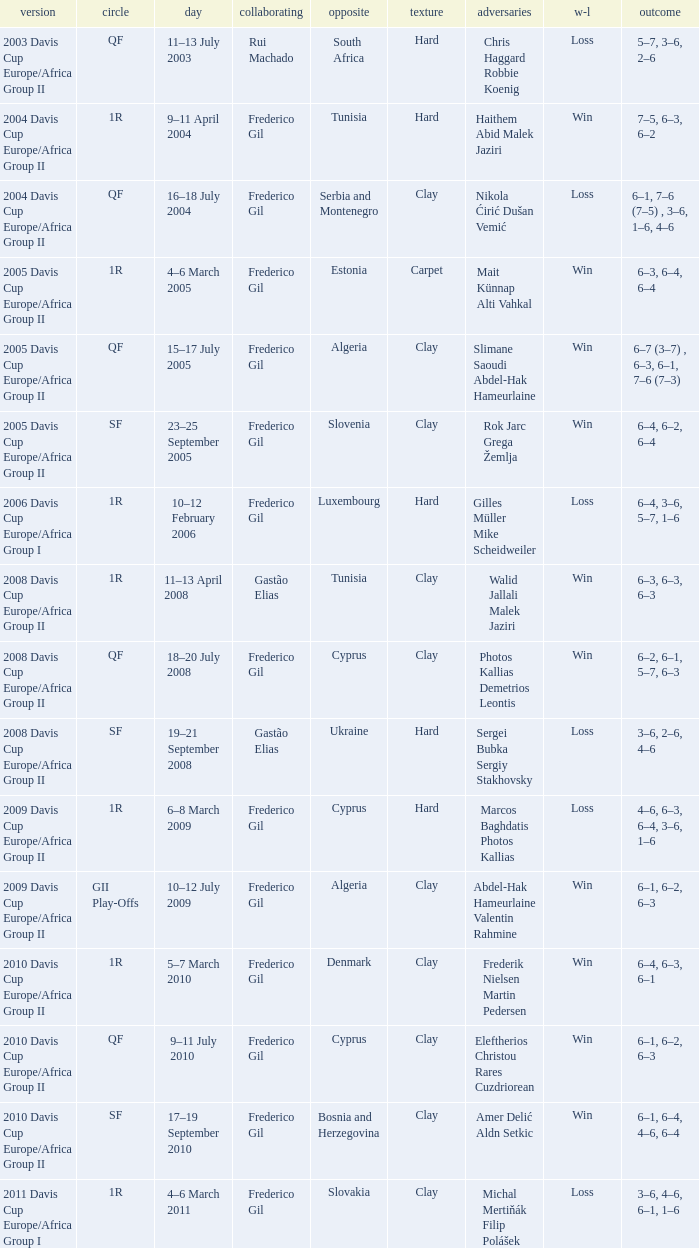How many rounds were there in the 2006 davis cup europe/africa group I? 1.0. Give me the full table as a dictionary. {'header': ['version', 'circle', 'day', 'collaborating', 'opposite', 'texture', 'adversaries', 'w-l', 'outcome'], 'rows': [['2003 Davis Cup Europe/Africa Group II', 'QF', '11–13 July 2003', 'Rui Machado', 'South Africa', 'Hard', 'Chris Haggard Robbie Koenig', 'Loss', '5–7, 3–6, 2–6'], ['2004 Davis Cup Europe/Africa Group II', '1R', '9–11 April 2004', 'Frederico Gil', 'Tunisia', 'Hard', 'Haithem Abid Malek Jaziri', 'Win', '7–5, 6–3, 6–2'], ['2004 Davis Cup Europe/Africa Group II', 'QF', '16–18 July 2004', 'Frederico Gil', 'Serbia and Montenegro', 'Clay', 'Nikola Ćirić Dušan Vemić', 'Loss', '6–1, 7–6 (7–5) , 3–6, 1–6, 4–6'], ['2005 Davis Cup Europe/Africa Group II', '1R', '4–6 March 2005', 'Frederico Gil', 'Estonia', 'Carpet', 'Mait Künnap Alti Vahkal', 'Win', '6–3, 6–4, 6–4'], ['2005 Davis Cup Europe/Africa Group II', 'QF', '15–17 July 2005', 'Frederico Gil', 'Algeria', 'Clay', 'Slimane Saoudi Abdel-Hak Hameurlaine', 'Win', '6–7 (3–7) , 6–3, 6–1, 7–6 (7–3)'], ['2005 Davis Cup Europe/Africa Group II', 'SF', '23–25 September 2005', 'Frederico Gil', 'Slovenia', 'Clay', 'Rok Jarc Grega Žemlja', 'Win', '6–4, 6–2, 6–4'], ['2006 Davis Cup Europe/Africa Group I', '1R', '10–12 February 2006', 'Frederico Gil', 'Luxembourg', 'Hard', 'Gilles Müller Mike Scheidweiler', 'Loss', '6–4, 3–6, 5–7, 1–6'], ['2008 Davis Cup Europe/Africa Group II', '1R', '11–13 April 2008', 'Gastão Elias', 'Tunisia', 'Clay', 'Walid Jallali Malek Jaziri', 'Win', '6–3, 6–3, 6–3'], ['2008 Davis Cup Europe/Africa Group II', 'QF', '18–20 July 2008', 'Frederico Gil', 'Cyprus', 'Clay', 'Photos Kallias Demetrios Leontis', 'Win', '6–2, 6–1, 5–7, 6–3'], ['2008 Davis Cup Europe/Africa Group II', 'SF', '19–21 September 2008', 'Gastão Elias', 'Ukraine', 'Hard', 'Sergei Bubka Sergiy Stakhovsky', 'Loss', '3–6, 2–6, 4–6'], ['2009 Davis Cup Europe/Africa Group II', '1R', '6–8 March 2009', 'Frederico Gil', 'Cyprus', 'Hard', 'Marcos Baghdatis Photos Kallias', 'Loss', '4–6, 6–3, 6–4, 3–6, 1–6'], ['2009 Davis Cup Europe/Africa Group II', 'GII Play-Offs', '10–12 July 2009', 'Frederico Gil', 'Algeria', 'Clay', 'Abdel-Hak Hameurlaine Valentin Rahmine', 'Win', '6–1, 6–2, 6–3'], ['2010 Davis Cup Europe/Africa Group II', '1R', '5–7 March 2010', 'Frederico Gil', 'Denmark', 'Clay', 'Frederik Nielsen Martin Pedersen', 'Win', '6–4, 6–3, 6–1'], ['2010 Davis Cup Europe/Africa Group II', 'QF', '9–11 July 2010', 'Frederico Gil', 'Cyprus', 'Clay', 'Eleftherios Christou Rares Cuzdriorean', 'Win', '6–1, 6–2, 6–3'], ['2010 Davis Cup Europe/Africa Group II', 'SF', '17–19 September 2010', 'Frederico Gil', 'Bosnia and Herzegovina', 'Clay', 'Amer Delić Aldn Setkic', 'Win', '6–1, 6–4, 4–6, 6–4'], ['2011 Davis Cup Europe/Africa Group I', '1R', '4–6 March 2011', 'Frederico Gil', 'Slovakia', 'Clay', 'Michal Mertiňák Filip Polášek', 'Loss', '3–6, 4–6, 6–1, 1–6']]} 